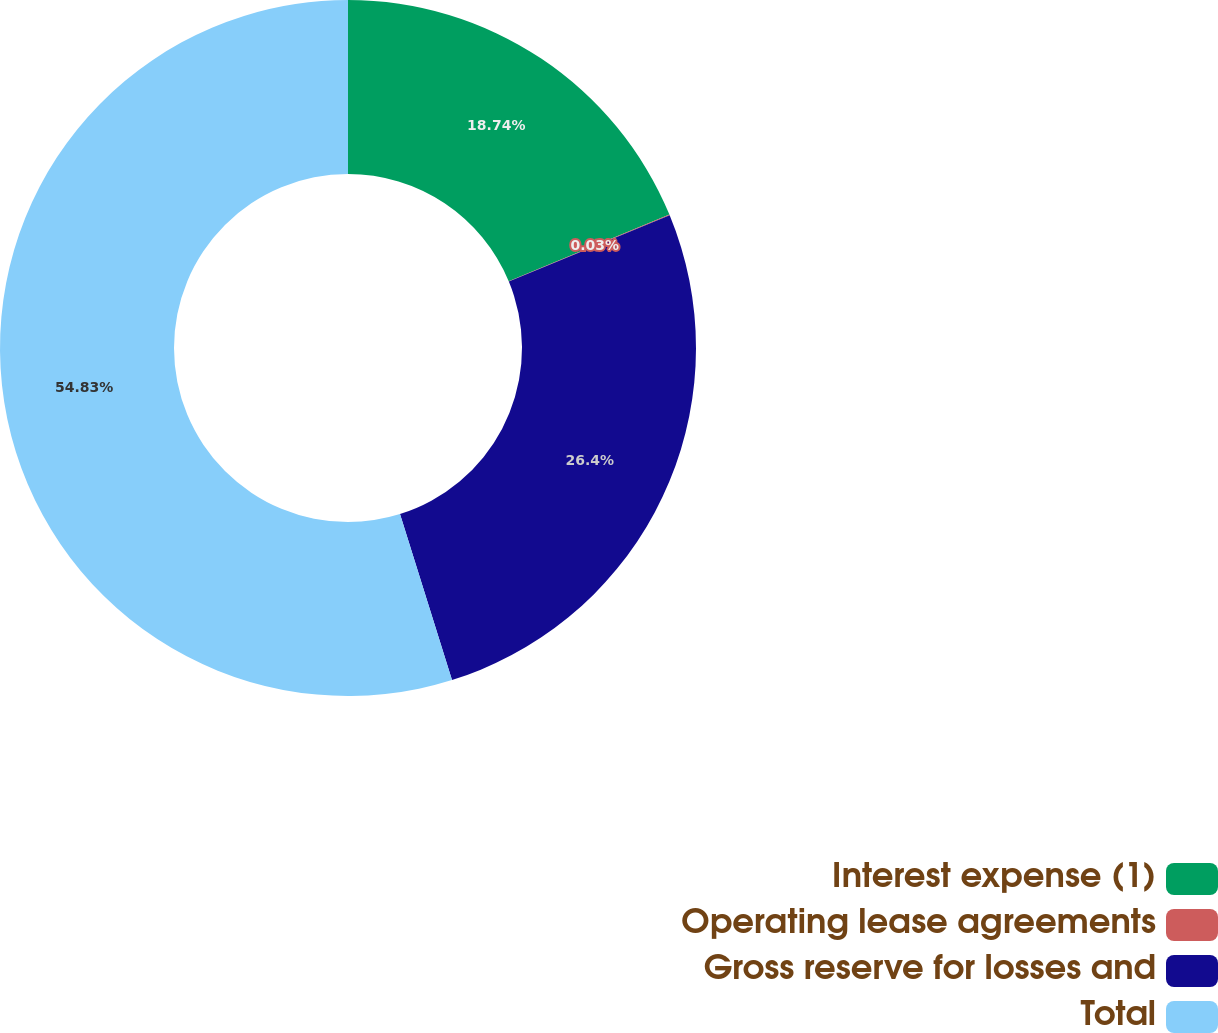Convert chart. <chart><loc_0><loc_0><loc_500><loc_500><pie_chart><fcel>Interest expense (1)<fcel>Operating lease agreements<fcel>Gross reserve for losses and<fcel>Total<nl><fcel>18.74%<fcel>0.03%<fcel>26.4%<fcel>54.83%<nl></chart> 